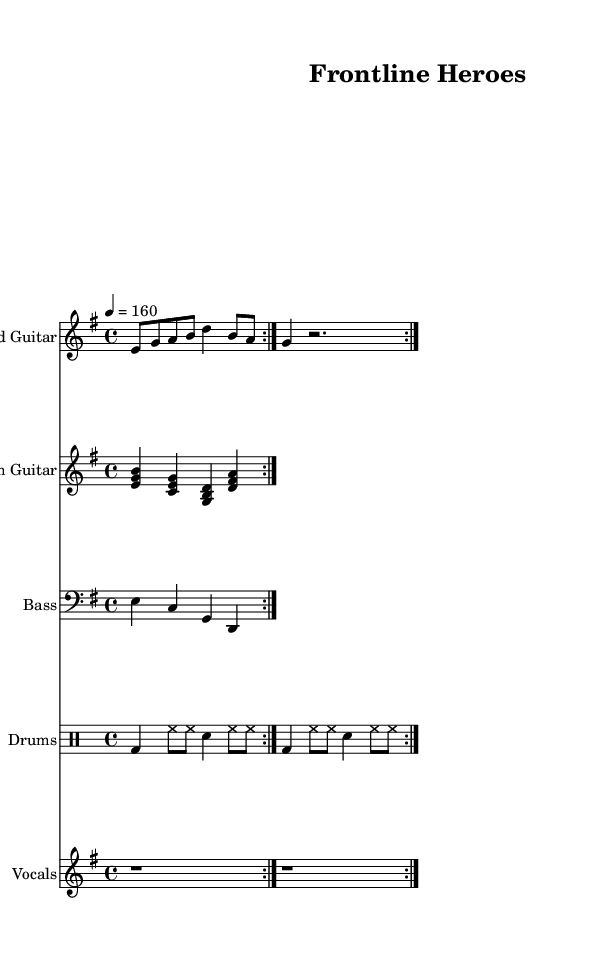What is the key signature of this music? The key signature of the piece is E minor, indicated by the absence of sharps or flats on the staff, with the key signature symbol placed at the beginning of the music.
Answer: E minor What is the time signature of this music? The time signature is 4/4, which is shown at the beginning of the score, indicating that there are four beats per measure and the quarter note receives one beat.
Answer: 4/4 What is the tempo marking of this piece? The tempo marking is indicated as "4 = 160," which means there are 160 beats per minute, and the quarter note is being counted as the beat unit.
Answer: 160 How many measures are in the repeated section? The repeated section consists of two measures of the lead guitar, two measures of the rhythm guitar, two measures of the bass, and two measures of the drums. Therefore, each part has two measures that repeat.
Answer: 2 What type of lyrics are included in this piece? The lyrics are written in a lyrical format beneath the vocal staff and express themes relevant to frontline struggles, capturing the emotional content expected in a hard rock song.
Answer: Vocals In what genre does this piece fit? The musical structure, instrumentation, and tempo are characteristic of the hard rock genre, which often features electric guitars, powerful rhythms, and themes of resilience and struggle, perfect for the subject matter.
Answer: Hard rock 